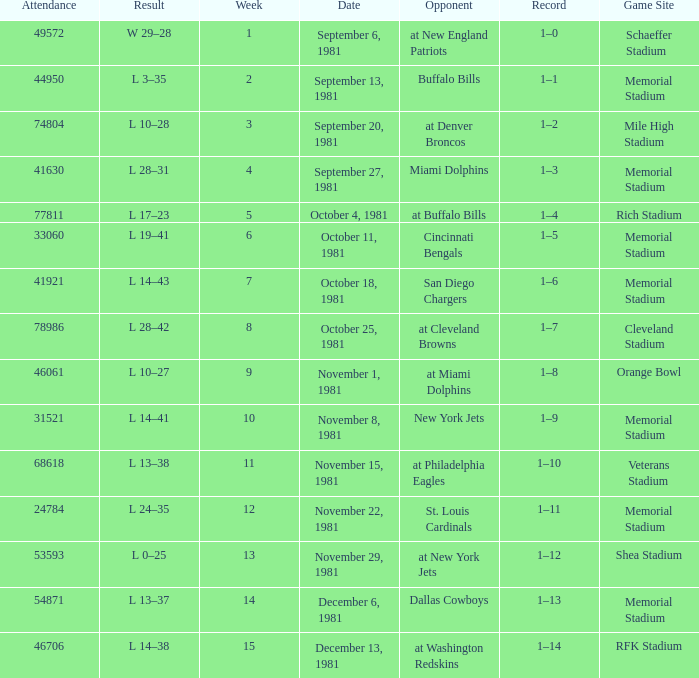When it is week 2 what is the record? 1–1. 